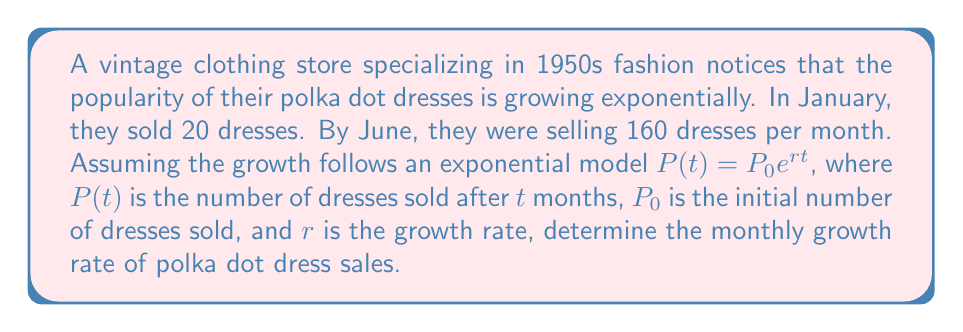Provide a solution to this math problem. Let's approach this step-by-step:

1) We know that the exponential growth model is $P(t) = P_0e^{rt}$

2) We have two data points:
   - At $t = 0$ (January), $P(0) = 20$
   - At $t = 5$ (June, 5 months later), $P(5) = 160$

3) Let's use these points in our equation:
   $20 = P_0e^{r(0)}$, so $P_0 = 20$
   $160 = 20e^{r(5)}$

4) Now we can solve for $r$:
   $$160 = 20e^{5r}$$

5) Divide both sides by 20:
   $$8 = e^{5r}$$

6) Take the natural log of both sides:
   $$\ln(8) = 5r$$

7) Solve for $r$:
   $$r = \frac{\ln(8)}{5} = \frac{\ln(2^3)}{5} = \frac{3\ln(2)}{5} \approx 0.4155$$

8) To express this as a percentage, multiply by 100:
   $$0.4155 * 100 \approx 41.55\%$$
Answer: 41.55% per month 